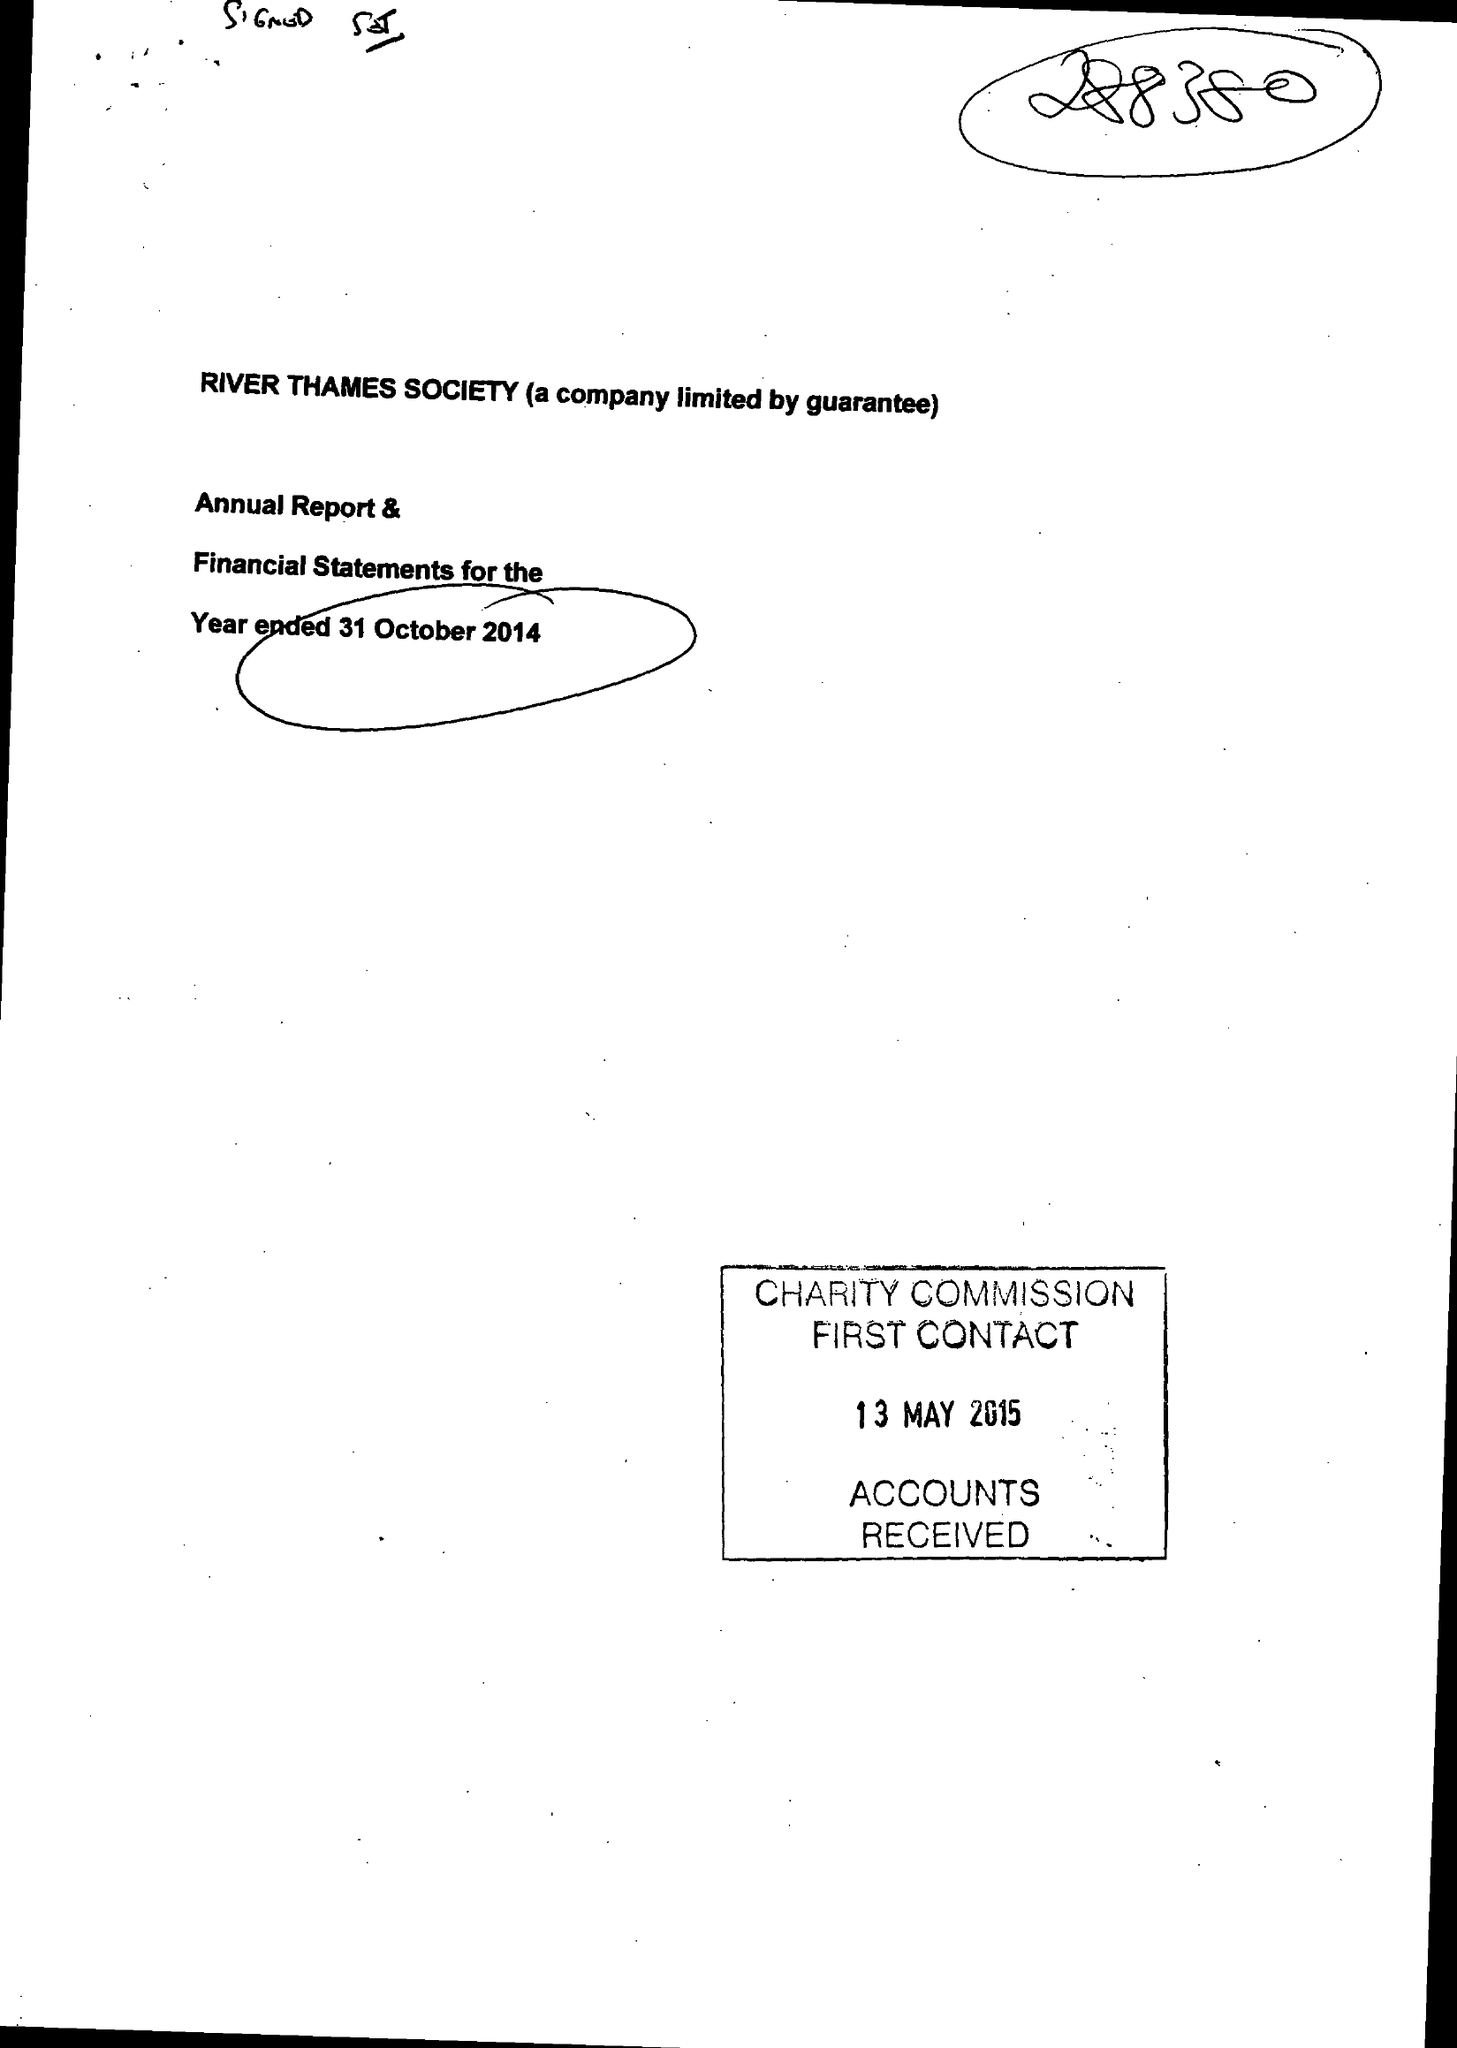What is the value for the address__postcode?
Answer the question using a single word or phrase. SL4 1JP 